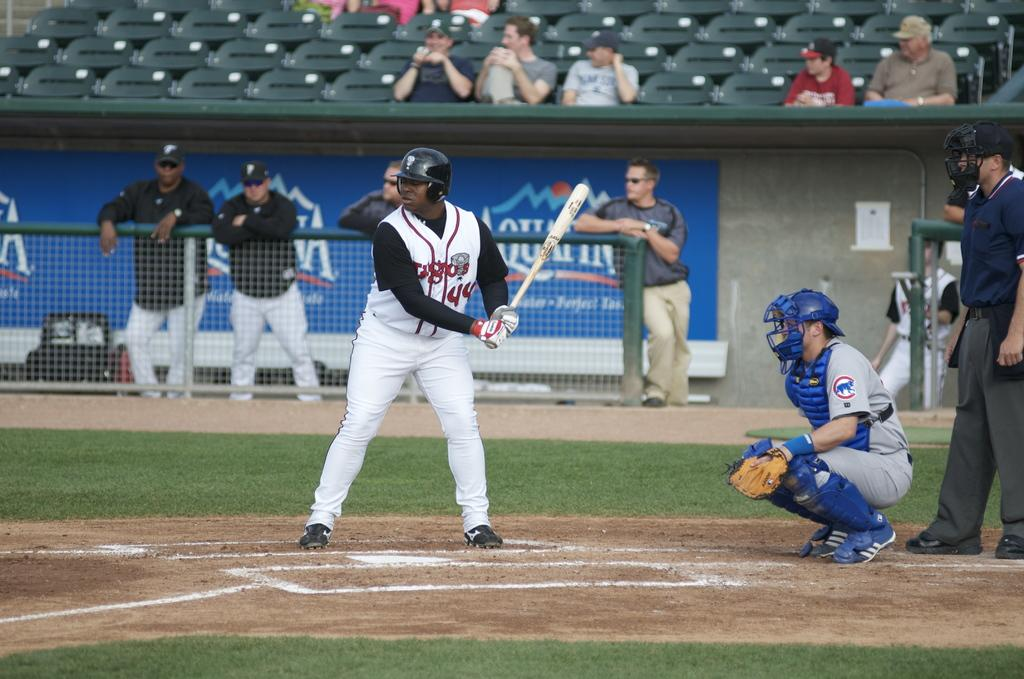<image>
Render a clear and concise summary of the photo. A baseball player at bat with 44 on his shirt. 